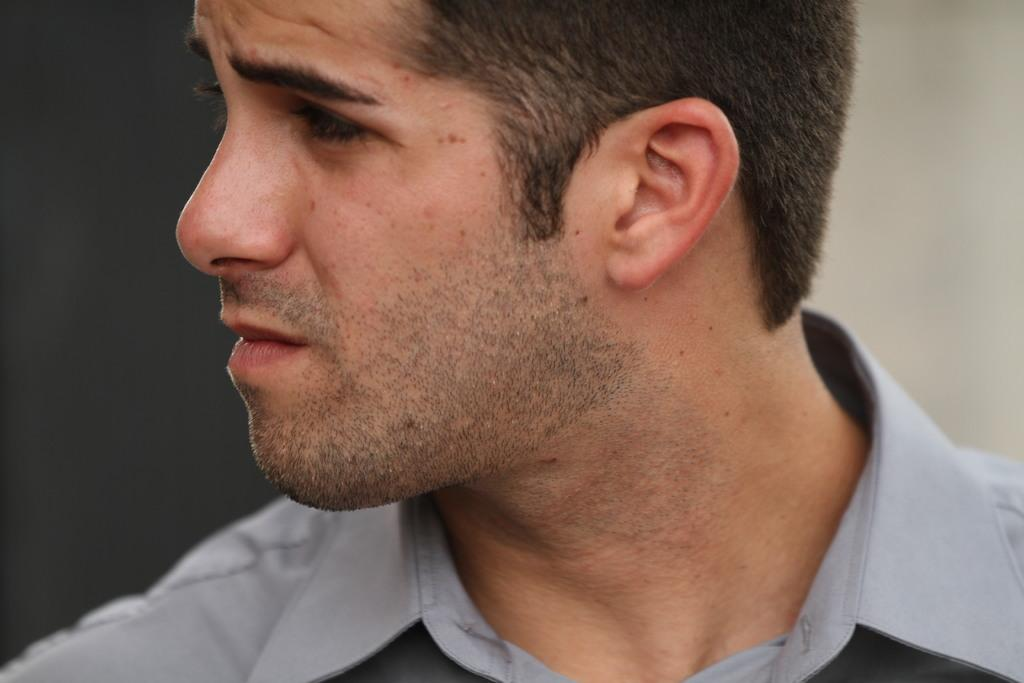What is the main subject of the image? There is a person in the image. What is the person wearing? The person is wearing a grey shirt. In which direction is the person looking? The person is looking to the left. Can you describe the background of the image? The background of the image is blurred. What time of day is it in the image, specifically the afternoon? The time of day is not mentioned in the image, so it cannot be determined if it is specifically the afternoon. 